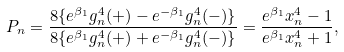Convert formula to latex. <formula><loc_0><loc_0><loc_500><loc_500>P _ { n } = \frac { 8 \{ e ^ { \beta _ { 1 } } g _ { n } ^ { 4 } ( + ) - e ^ { - \beta _ { 1 } } g _ { n } ^ { 4 } ( - ) \} } { 8 \{ e ^ { \beta _ { 1 } } g _ { n } ^ { 4 } ( + ) + e ^ { - \beta _ { 1 } } g _ { n } ^ { 4 } ( - ) \} } = \frac { e ^ { \beta _ { 1 } } x _ { n } ^ { 4 } - 1 } { e ^ { \beta _ { 1 } } x _ { n } ^ { 4 } + 1 } ,</formula> 